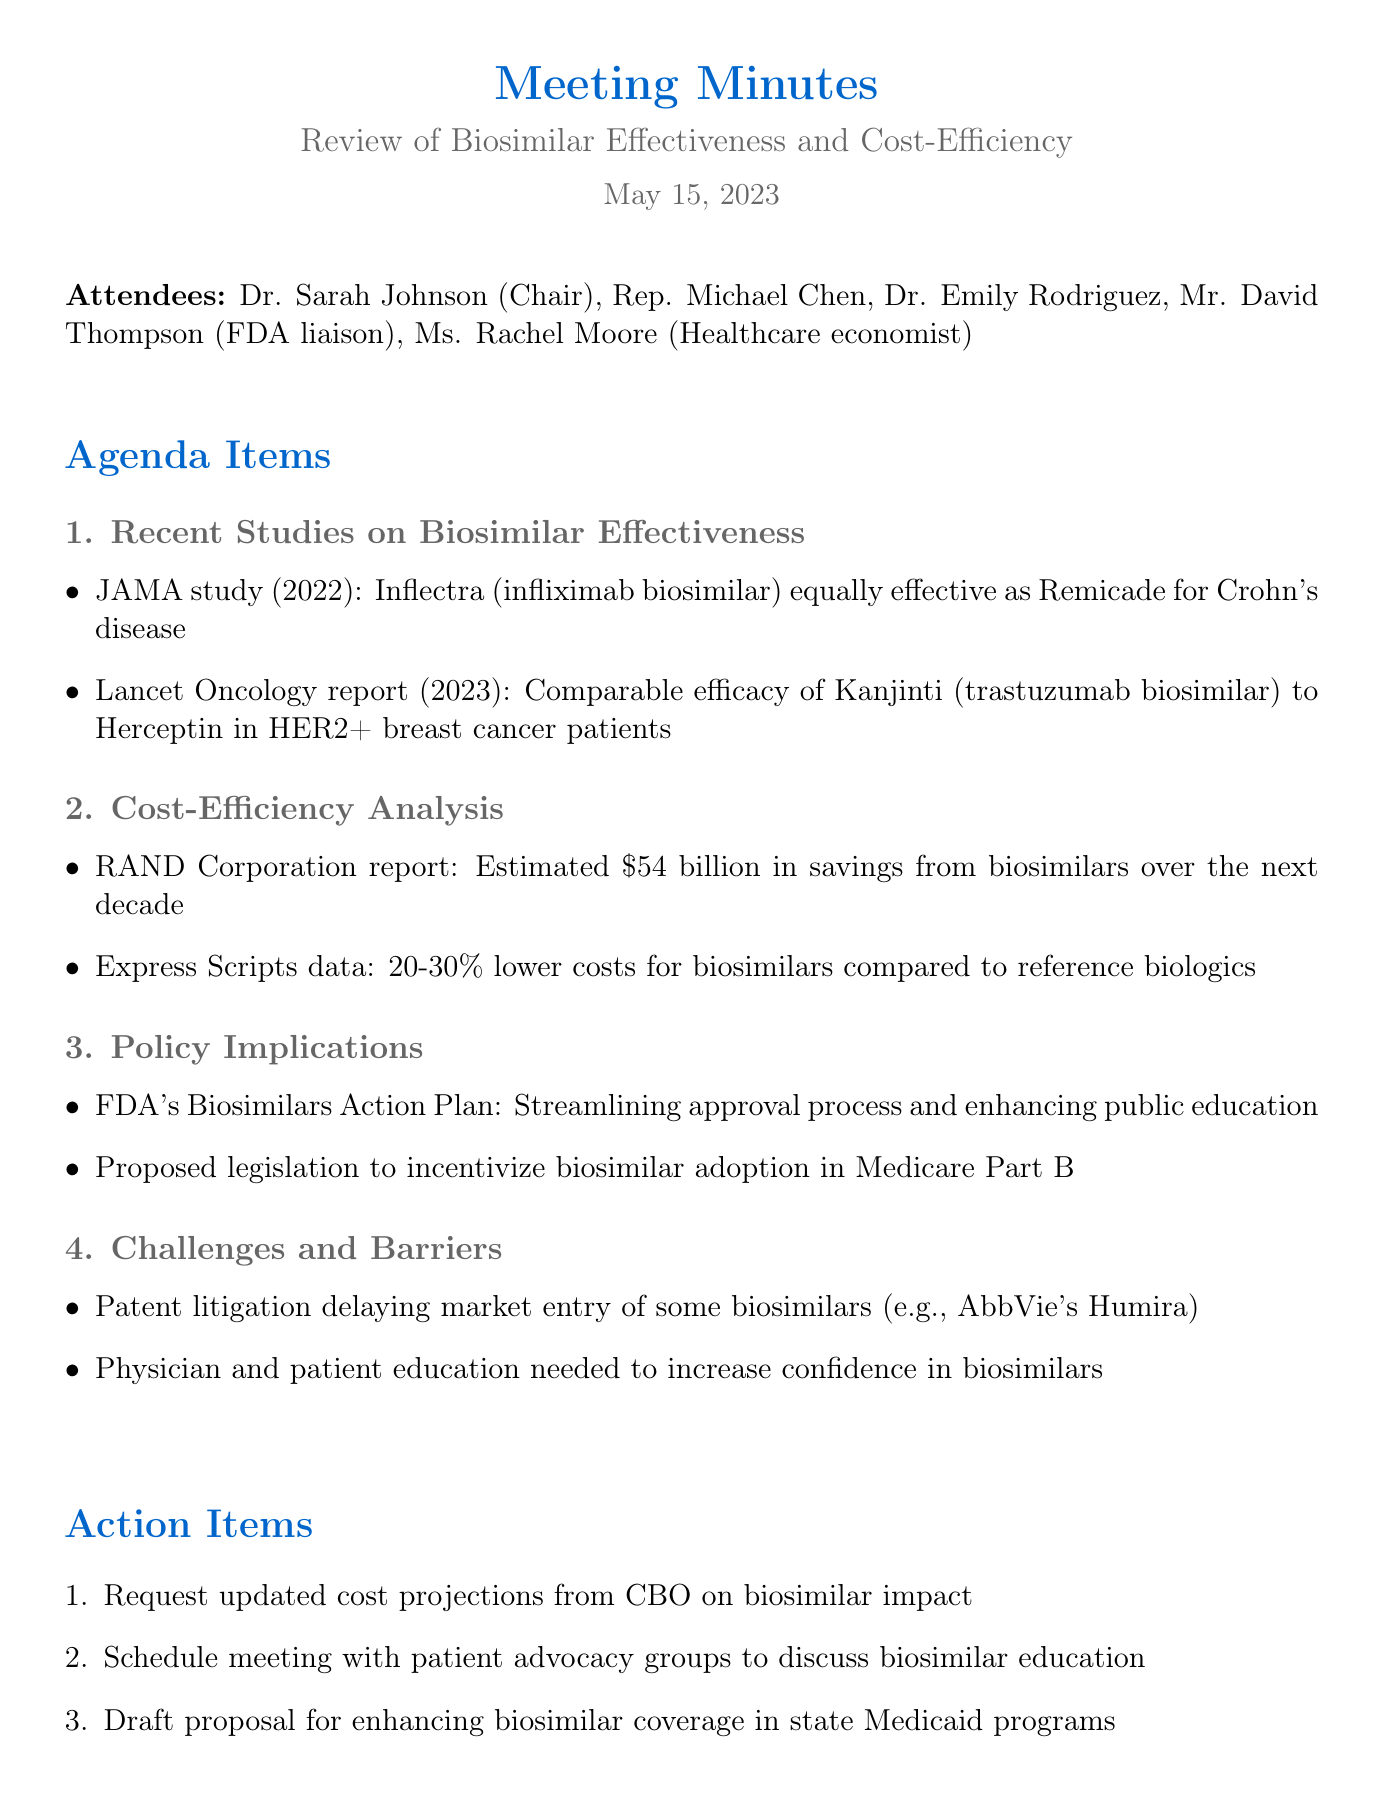What is the date of the meeting? The date of the meeting is clearly stated in the document as May 15, 2023.
Answer: May 15, 2023 Who chaired the meeting? The document mentions Dr. Sarah Johnson as the Chair of the meeting.
Answer: Dr. Sarah Johnson What financial savings does the RAND Corporation estimate from biosimilars? The document provides the estimate from the RAND Corporation as $54 billion in savings over the next decade.
Answer: $54 billion Which medication was found equally effective as Remicade for Crohn's disease? The document specifies that Inflectra (infliximab biosimilar) was shown to be equally effective as Remicade.
Answer: Inflectra What is one challenge mentioned regarding biosimilars? The document highlights patent litigation as one of the challenges delaying market entry of some biosimilars.
Answer: Patent litigation What does the FDA's Biosimilars Action Plan aim to enhance? The document notes that the FDA's Biosimilars Action Plan aims to enhance public education.
Answer: Public education How much lower are biosimilar costs compared to reference biologics according to Express Scripts data? The document indicates that biosimilars are 20-30% lower in costs compared to reference biologics.
Answer: 20-30% What is one action item discussed in the meeting? The document lists several action items, including requesting updated cost projections from the CBO on biosimilar impact.
Answer: Request updated cost projections from CBO What is the Lancet Oncology report year mentioned? The document mentions that the Lancet Oncology report was published in 2023.
Answer: 2023 